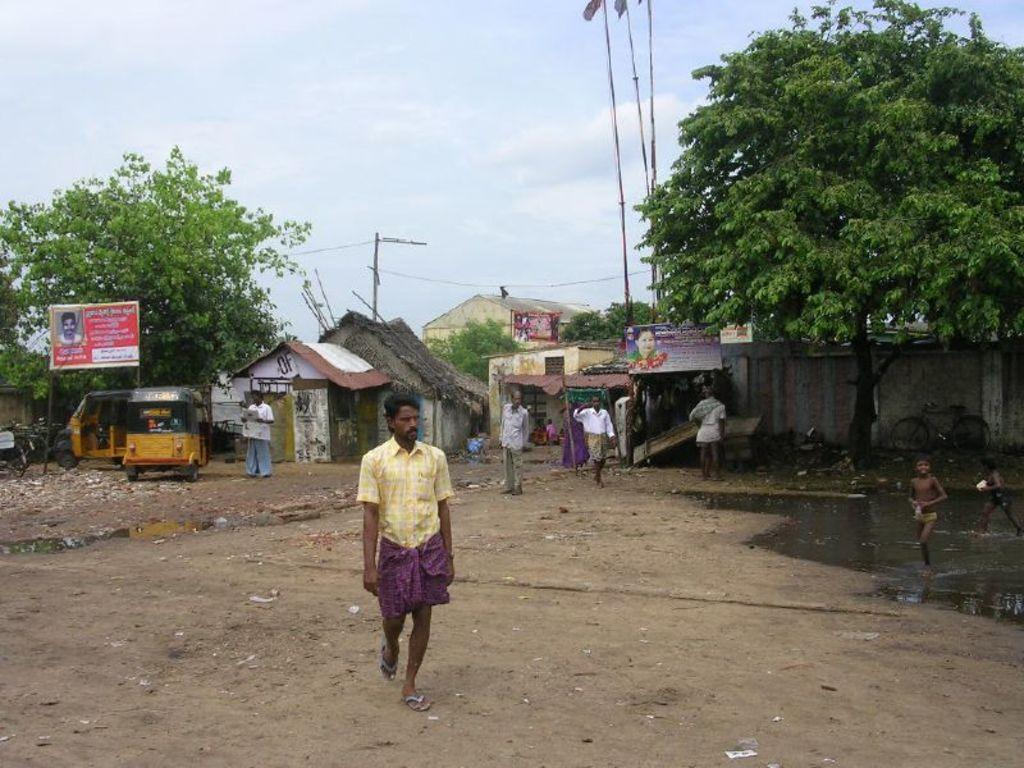What is the main action of the person in the image? There is a person walking in the image. What can be seen in the background of the image? There is a group of people standing in the background. What type of structures are present in the image? There are huts and houses in the image. What natural element is visible in the image? There is water visible in the image. What type of decorations are present in the image? There are banners in the image. What mode of transportation is present in the image? There are vehicles in the image. What type of vegetation is present in the image? There are trees in the image. What type of flag-related objects are present in the image? There are poles with flags in the image. What part of the environment is visible in the image? The sky is visible in the image. What type of pest is visible in the image? There is no pest visible in the image. What type of farmer is present in the image? There is no farmer present in the image. 